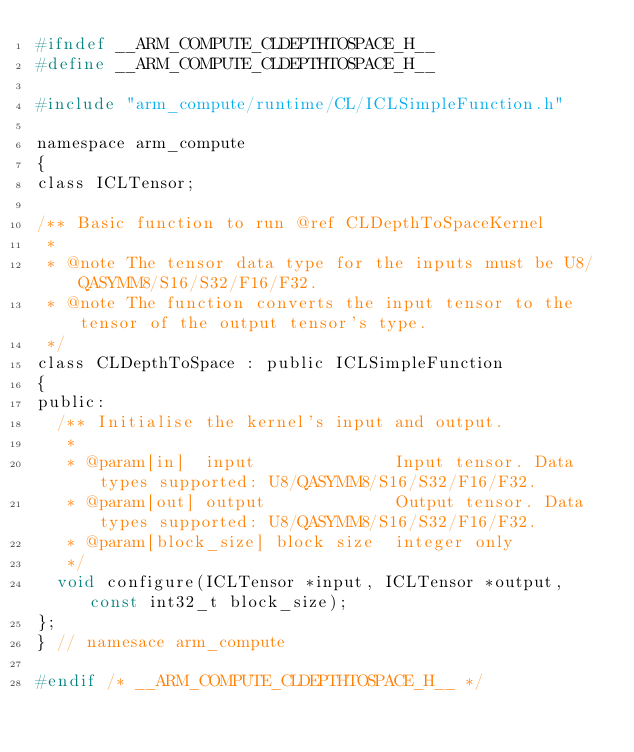Convert code to text. <code><loc_0><loc_0><loc_500><loc_500><_C_>#ifndef __ARM_COMPUTE_CLDEPTHTOSPACE_H__
#define __ARM_COMPUTE_CLDEPTHTOSPACE_H__

#include "arm_compute/runtime/CL/ICLSimpleFunction.h"

namespace arm_compute
{
class ICLTensor;

/** Basic function to run @ref CLDepthToSpaceKernel
 *
 * @note The tensor data type for the inputs must be U8/QASYMM8/S16/S32/F16/F32.
 * @note The function converts the input tensor to the tensor of the output tensor's type.
 */
class CLDepthToSpace : public ICLSimpleFunction
{
public:
  /** Initialise the kernel's input and output.
   *
   * @param[in]  input              Input tensor. Data types supported: U8/QASYMM8/S16/S32/F16/F32.
   * @param[out] output             Output tensor. Data types supported: U8/QASYMM8/S16/S32/F16/F32.
   * @param[block_size] block size  integer only
   */
  void configure(ICLTensor *input, ICLTensor *output, const int32_t block_size);
};
} // namesace arm_compute

#endif /* __ARM_COMPUTE_CLDEPTHTOSPACE_H__ */
</code> 